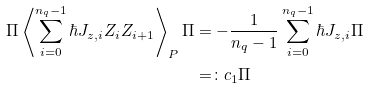<formula> <loc_0><loc_0><loc_500><loc_500>\Pi \left \langle \sum _ { i = 0 } ^ { n _ { q } - 1 } \hbar { J } _ { z , i } Z _ { i } Z _ { i + 1 } \right \rangle _ { P } \Pi & = - \frac { 1 } { n _ { q } - 1 } \sum _ { i = 0 } ^ { n _ { q } - 1 } \hbar { J } _ { z , i } \Pi \\ & = \colon c _ { 1 } \Pi</formula> 